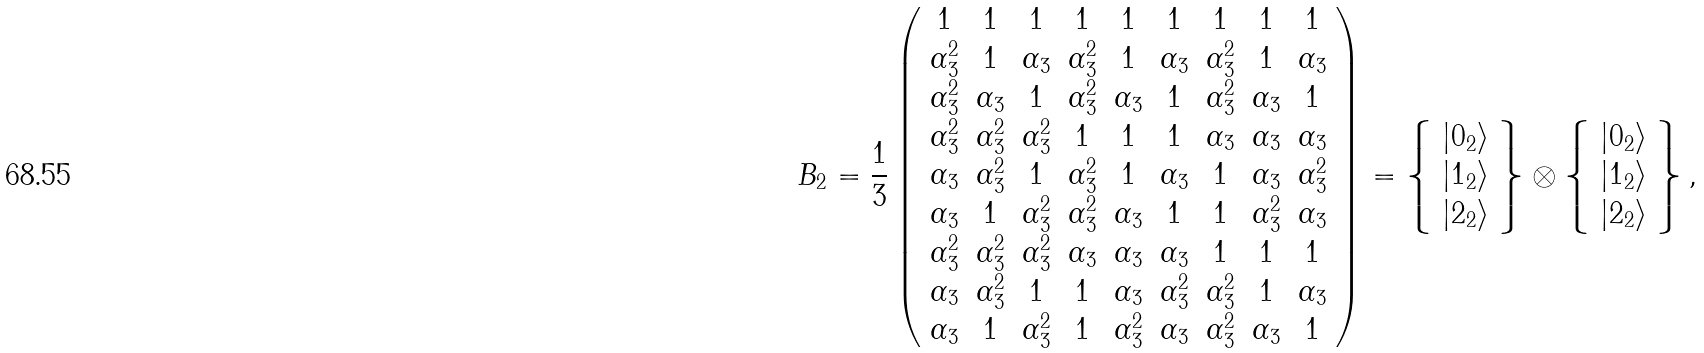<formula> <loc_0><loc_0><loc_500><loc_500>B _ { 2 } = \frac { 1 } { 3 } \left ( \begin{array} { c c c c c c c c c } 1 & 1 & 1 & 1 & 1 & 1 & 1 & 1 & 1 \\ \alpha _ { 3 } ^ { 2 } & 1 & \alpha _ { 3 } & \alpha _ { 3 } ^ { 2 } & 1 & \alpha _ { 3 } & \alpha _ { 3 } ^ { 2 } & 1 & \alpha _ { 3 } \\ \alpha _ { 3 } ^ { 2 } & \alpha _ { 3 } & 1 & \alpha _ { 3 } ^ { 2 } & \alpha _ { 3 } & 1 & \alpha _ { 3 } ^ { 2 } & \alpha _ { 3 } & 1 \\ \alpha _ { 3 } ^ { 2 } & \alpha _ { 3 } ^ { 2 } & \alpha _ { 3 } ^ { 2 } & 1 & 1 & 1 & \alpha _ { 3 } & \alpha _ { 3 } & \alpha _ { 3 } \\ \alpha _ { 3 } & \alpha _ { 3 } ^ { 2 } & 1 & \alpha _ { 3 } ^ { 2 } & 1 & \alpha _ { 3 } & 1 & \alpha _ { 3 } & \alpha _ { 3 } ^ { 2 } \\ \alpha _ { 3 } & 1 & \alpha _ { 3 } ^ { 2 } & \alpha _ { 3 } ^ { 2 } & \alpha _ { 3 } & 1 & 1 & \alpha _ { 3 } ^ { 2 } & \alpha _ { 3 } \\ \alpha _ { 3 } ^ { 2 } & \alpha _ { 3 } ^ { 2 } & \alpha _ { 3 } ^ { 2 } & \alpha _ { 3 } & \alpha _ { 3 } & \alpha _ { 3 } & 1 & 1 & 1 \\ \alpha _ { 3 } & \alpha _ { 3 } ^ { 2 } & 1 & 1 & \alpha _ { 3 } & \alpha _ { 3 } ^ { 2 } & \alpha _ { 3 } ^ { 2 } & 1 & \alpha _ { 3 } \\ \alpha _ { 3 } & 1 & \alpha _ { 3 } ^ { 2 } & 1 & \alpha _ { 3 } ^ { 2 } & \alpha _ { 3 } & \alpha _ { 3 } ^ { 2 } & \alpha _ { 3 } & 1 \end{array} \right ) = \left \{ \begin{array} { c } | 0 _ { 2 } \rangle \\ | 1 _ { 2 } \rangle \\ | 2 _ { 2 } \rangle \end{array} \right \} \otimes \left \{ \begin{array} { c } | 0 _ { 2 } \rangle \\ | 1 _ { 2 } \rangle \\ | 2 _ { 2 } \rangle \end{array} \right \} ,</formula> 